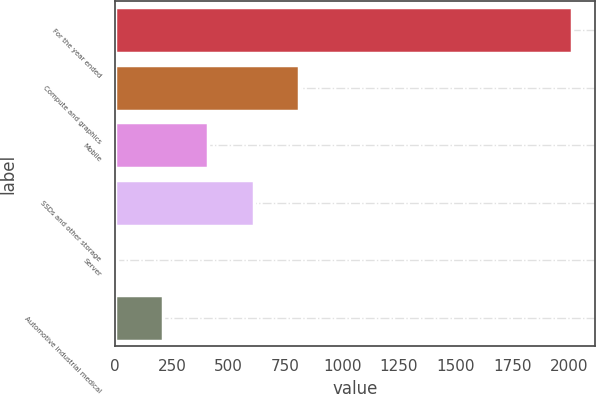<chart> <loc_0><loc_0><loc_500><loc_500><bar_chart><fcel>For the year ended<fcel>Compute and graphics<fcel>Mobile<fcel>SSDs and other storage<fcel>Server<fcel>Automotive industrial medical<nl><fcel>2014<fcel>811.6<fcel>410.8<fcel>611.2<fcel>10<fcel>210.4<nl></chart> 